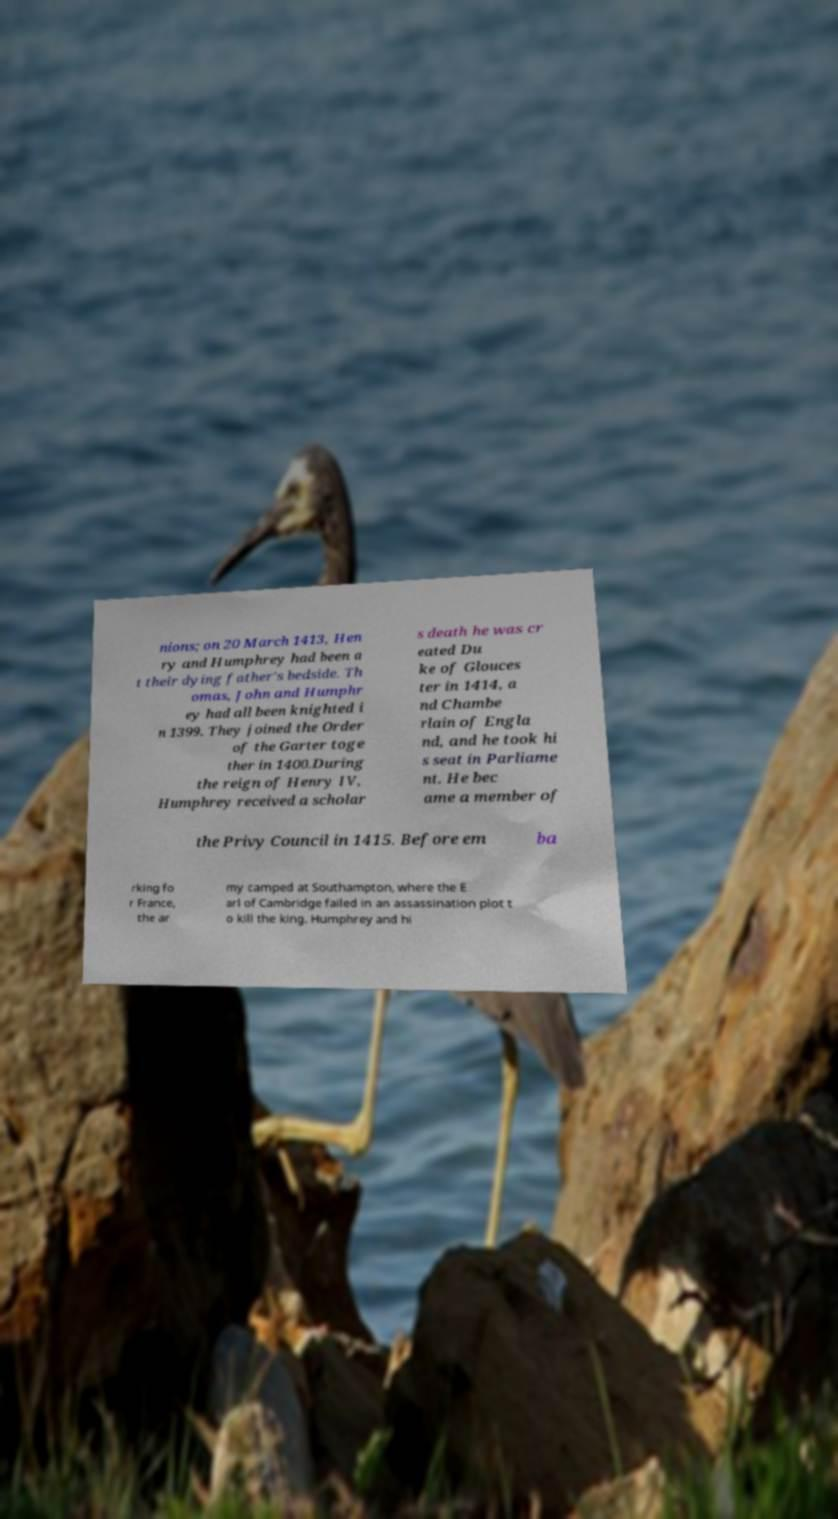What messages or text are displayed in this image? I need them in a readable, typed format. nions; on 20 March 1413, Hen ry and Humphrey had been a t their dying father's bedside. Th omas, John and Humphr ey had all been knighted i n 1399. They joined the Order of the Garter toge ther in 1400.During the reign of Henry IV, Humphrey received a scholar s death he was cr eated Du ke of Glouces ter in 1414, a nd Chambe rlain of Engla nd, and he took hi s seat in Parliame nt. He bec ame a member of the Privy Council in 1415. Before em ba rking fo r France, the ar my camped at Southampton, where the E arl of Cambridge failed in an assassination plot t o kill the king. Humphrey and hi 